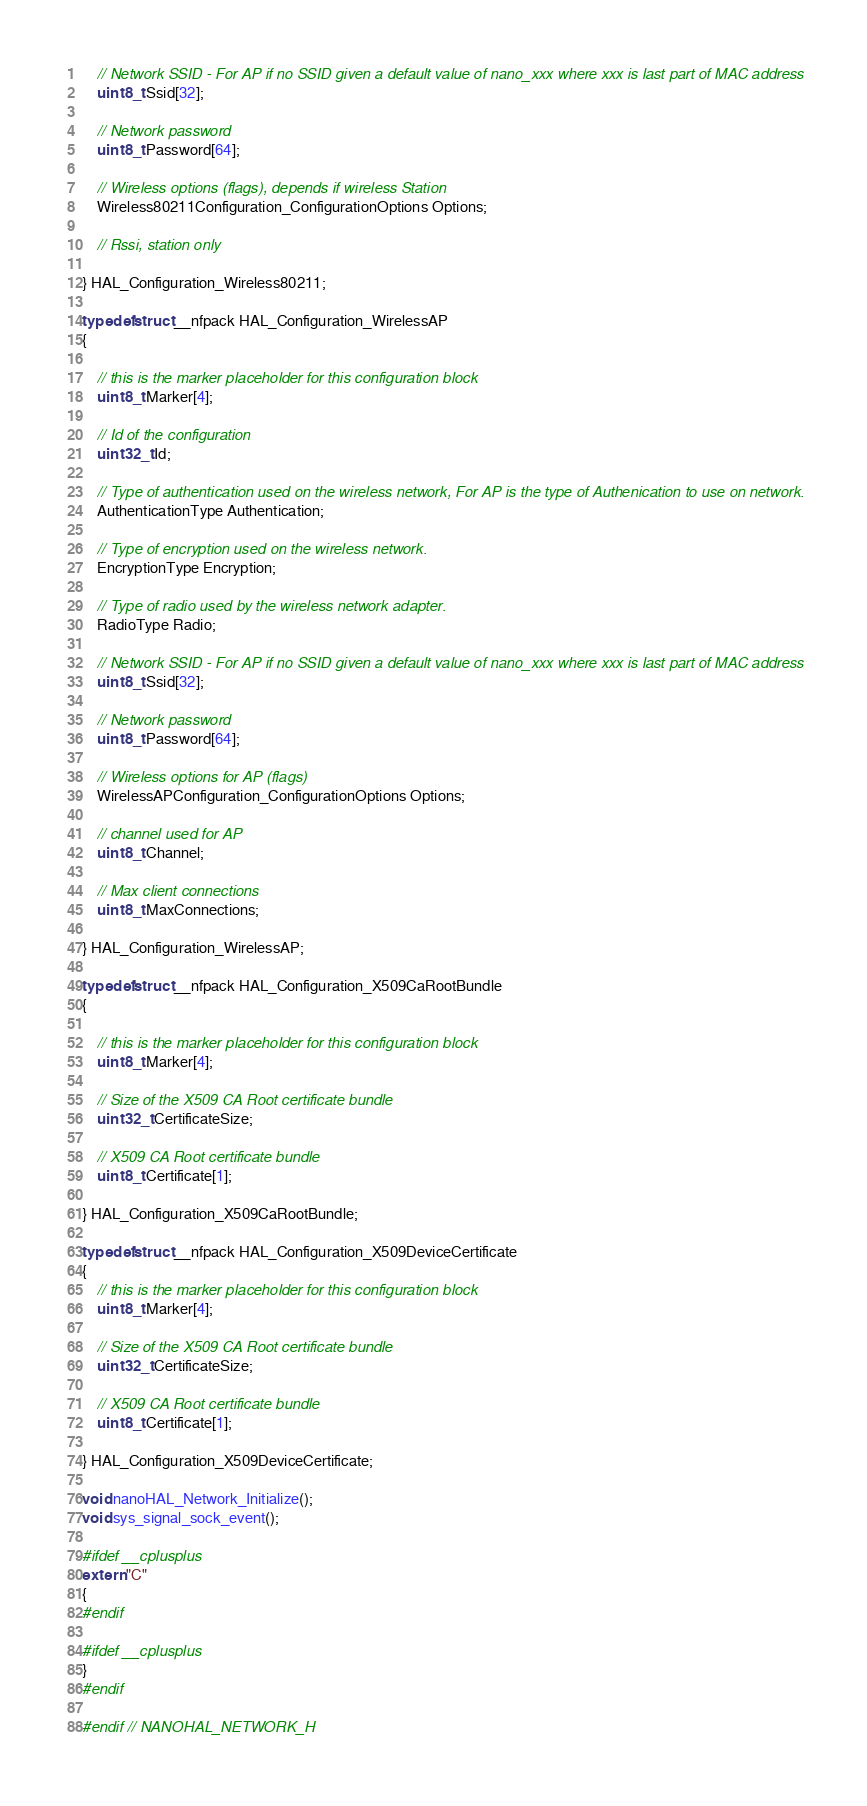Convert code to text. <code><loc_0><loc_0><loc_500><loc_500><_C_>    // Network SSID - For AP if no SSID given a default value of nano_xxx where xxx is last part of MAC address
    uint8_t Ssid[32];

    // Network password
    uint8_t Password[64];

    // Wireless options (flags), depends if wireless Station
    Wireless80211Configuration_ConfigurationOptions Options;

    // Rssi, station only

} HAL_Configuration_Wireless80211;

typedef struct __nfpack HAL_Configuration_WirelessAP
{

    // this is the marker placeholder for this configuration block
    uint8_t Marker[4];

    // Id of the configuration
    uint32_t Id;

    // Type of authentication used on the wireless network, For AP is the type of Authenication to use on network.
    AuthenticationType Authentication;

    // Type of encryption used on the wireless network.
    EncryptionType Encryption;

    // Type of radio used by the wireless network adapter.
    RadioType Radio;

    // Network SSID - For AP if no SSID given a default value of nano_xxx where xxx is last part of MAC address
    uint8_t Ssid[32];

    // Network password
    uint8_t Password[64];

    // Wireless options for AP (flags)
    WirelessAPConfiguration_ConfigurationOptions Options;

    // channel used for AP
    uint8_t Channel;

    // Max client connections
    uint8_t MaxConnections;

} HAL_Configuration_WirelessAP;

typedef struct __nfpack HAL_Configuration_X509CaRootBundle
{

    // this is the marker placeholder for this configuration block
    uint8_t Marker[4];

    // Size of the X509 CA Root certificate bundle
    uint32_t CertificateSize;

    // X509 CA Root certificate bundle
    uint8_t Certificate[1];

} HAL_Configuration_X509CaRootBundle;

typedef struct __nfpack HAL_Configuration_X509DeviceCertificate
{
    // this is the marker placeholder for this configuration block
    uint8_t Marker[4];

    // Size of the X509 CA Root certificate bundle
    uint32_t CertificateSize;

    // X509 CA Root certificate bundle
    uint8_t Certificate[1];

} HAL_Configuration_X509DeviceCertificate;

void nanoHAL_Network_Initialize();
void sys_signal_sock_event();

#ifdef __cplusplus
extern "C"
{
#endif

#ifdef __cplusplus
}
#endif

#endif // NANOHAL_NETWORK_H
</code> 